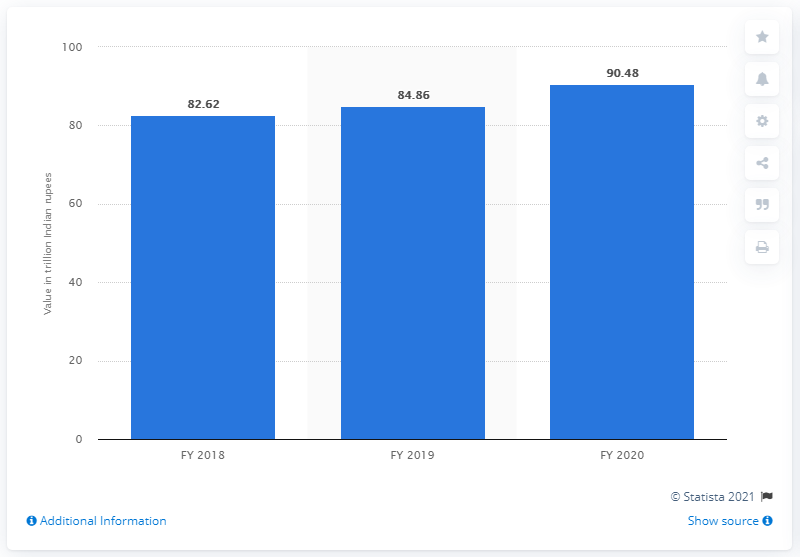Outline some significant characteristics in this image. At the end of the fiscal year 2020, the total value of deposits at public sector banks in India was 90,480 crores. 